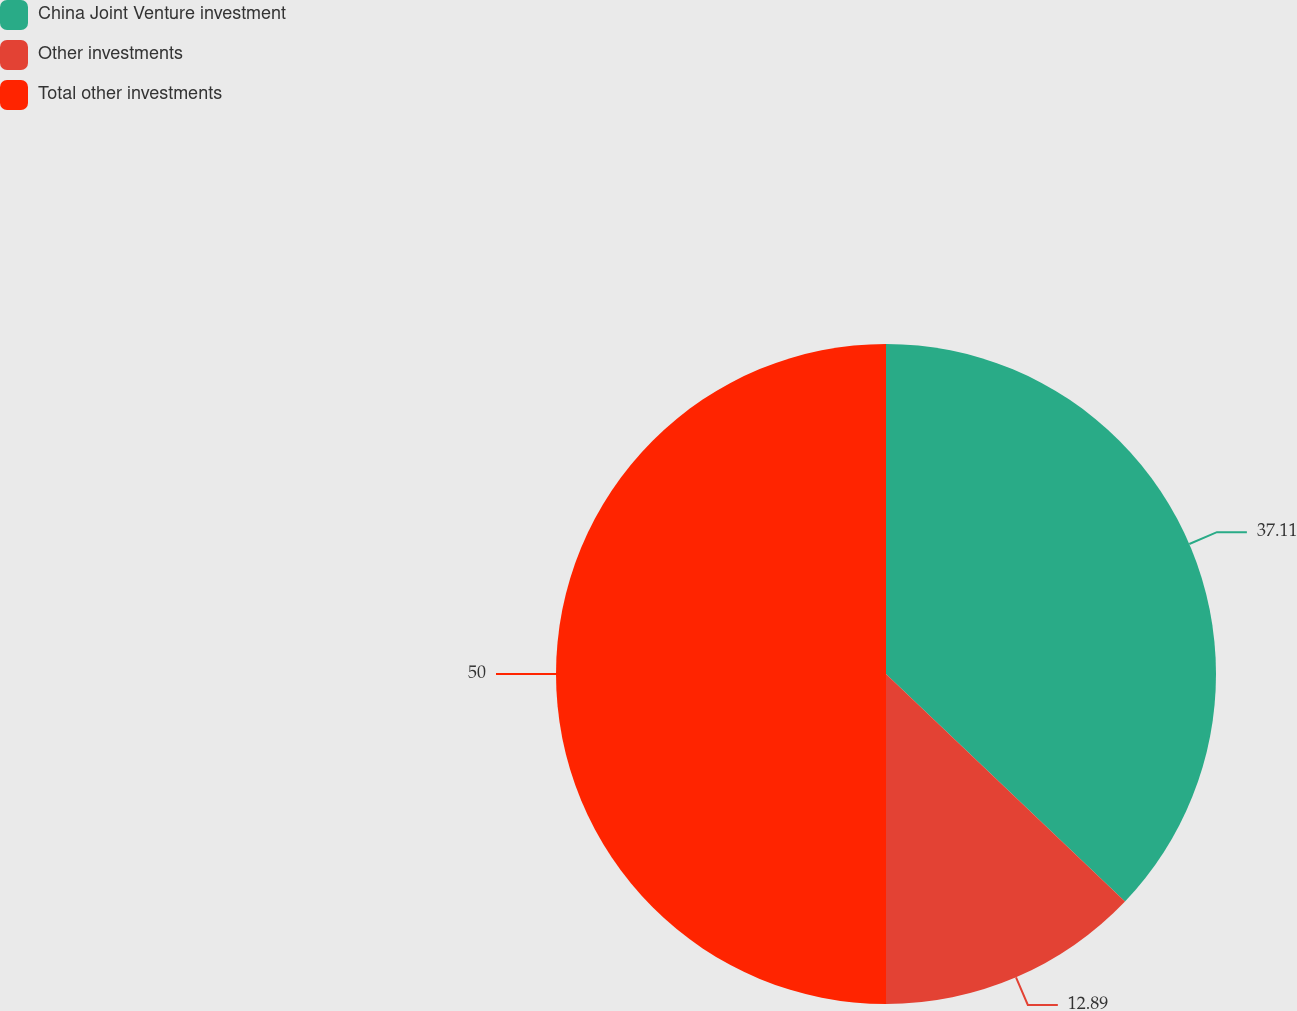Convert chart to OTSL. <chart><loc_0><loc_0><loc_500><loc_500><pie_chart><fcel>China Joint Venture investment<fcel>Other investments<fcel>Total other investments<nl><fcel>37.11%<fcel>12.89%<fcel>50.0%<nl></chart> 